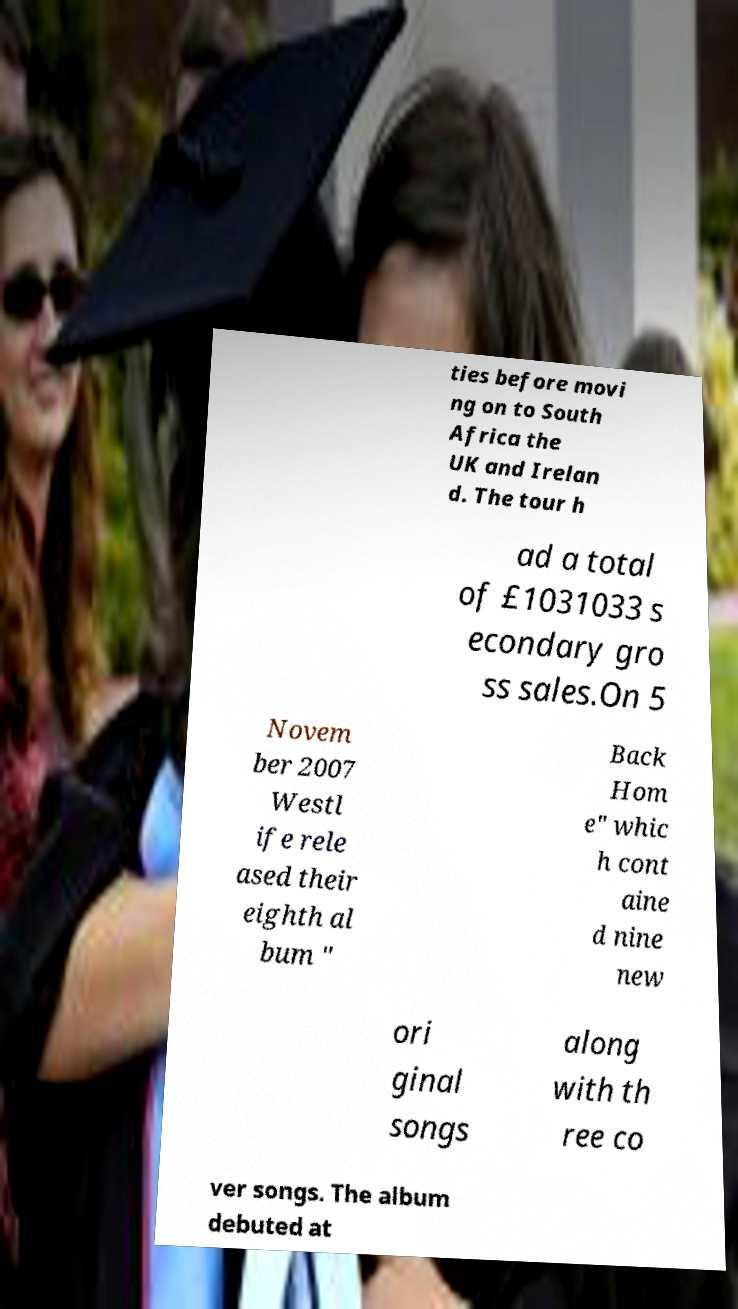There's text embedded in this image that I need extracted. Can you transcribe it verbatim? ties before movi ng on to South Africa the UK and Irelan d. The tour h ad a total of £1031033 s econdary gro ss sales.On 5 Novem ber 2007 Westl ife rele ased their eighth al bum " Back Hom e" whic h cont aine d nine new ori ginal songs along with th ree co ver songs. The album debuted at 